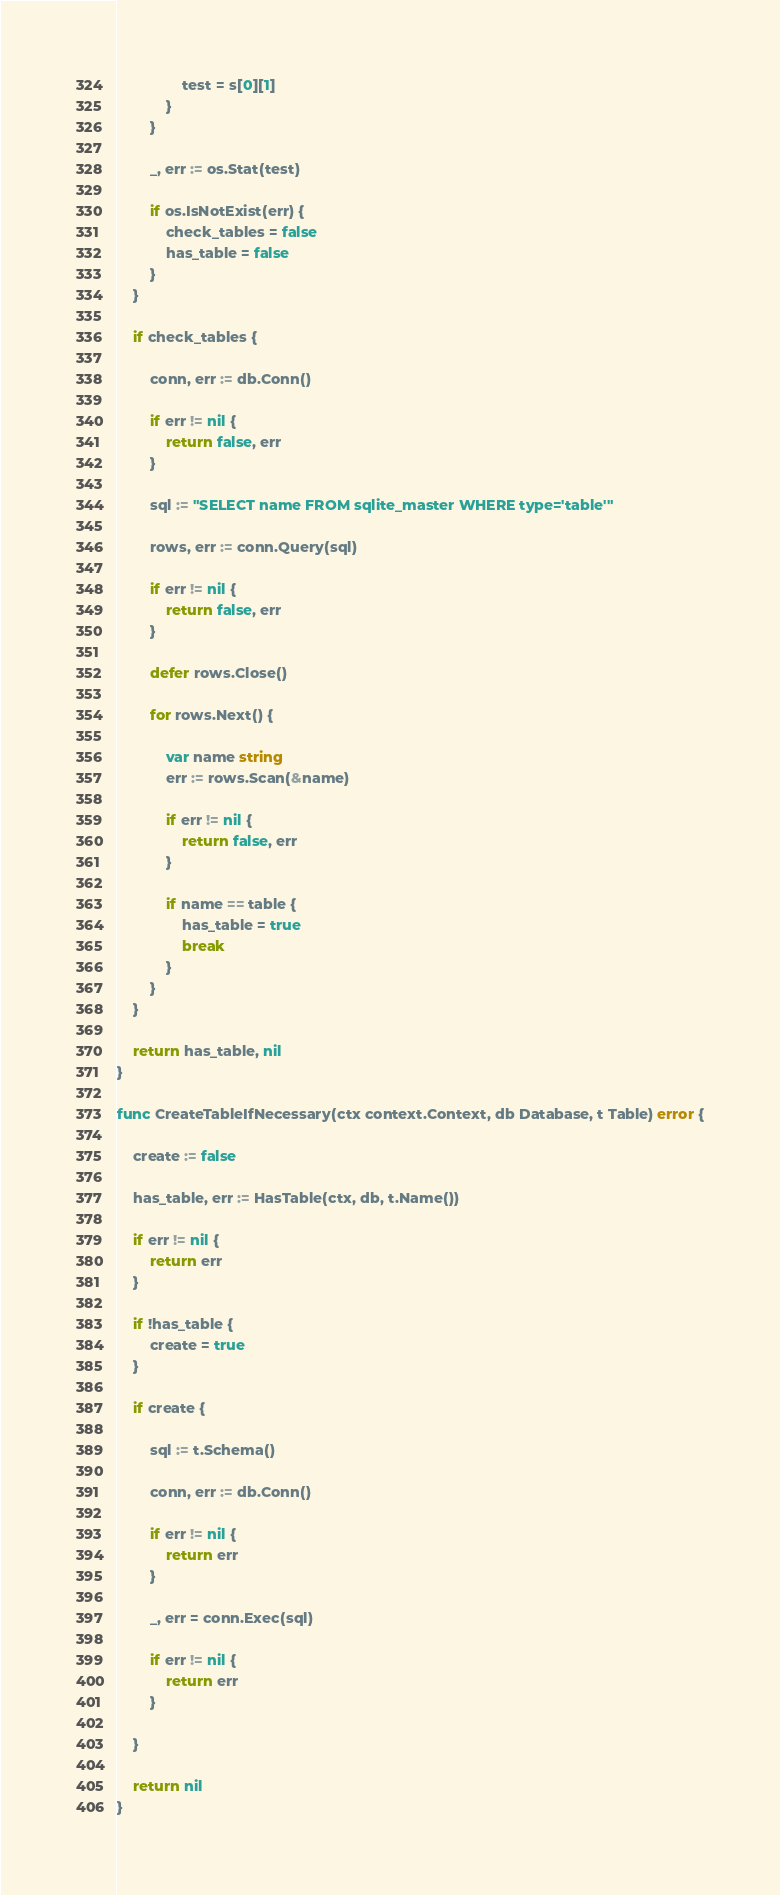Convert code to text. <code><loc_0><loc_0><loc_500><loc_500><_Go_>				test = s[0][1]
			}
		}

		_, err := os.Stat(test)

		if os.IsNotExist(err) {
			check_tables = false
			has_table = false
		}
	}

	if check_tables {

		conn, err := db.Conn()

		if err != nil {
			return false, err
		}

		sql := "SELECT name FROM sqlite_master WHERE type='table'"

		rows, err := conn.Query(sql)

		if err != nil {
			return false, err
		}

		defer rows.Close()

		for rows.Next() {

			var name string
			err := rows.Scan(&name)

			if err != nil {
				return false, err
			}

			if name == table {
				has_table = true
				break
			}
		}
	}

	return has_table, nil
}

func CreateTableIfNecessary(ctx context.Context, db Database, t Table) error {

	create := false

	has_table, err := HasTable(ctx, db, t.Name())

	if err != nil {
		return err
	}

	if !has_table {
		create = true
	}

	if create {

		sql := t.Schema()

		conn, err := db.Conn()

		if err != nil {
			return err
		}

		_, err = conn.Exec(sql)

		if err != nil {
			return err
		}

	}

	return nil
}
</code> 